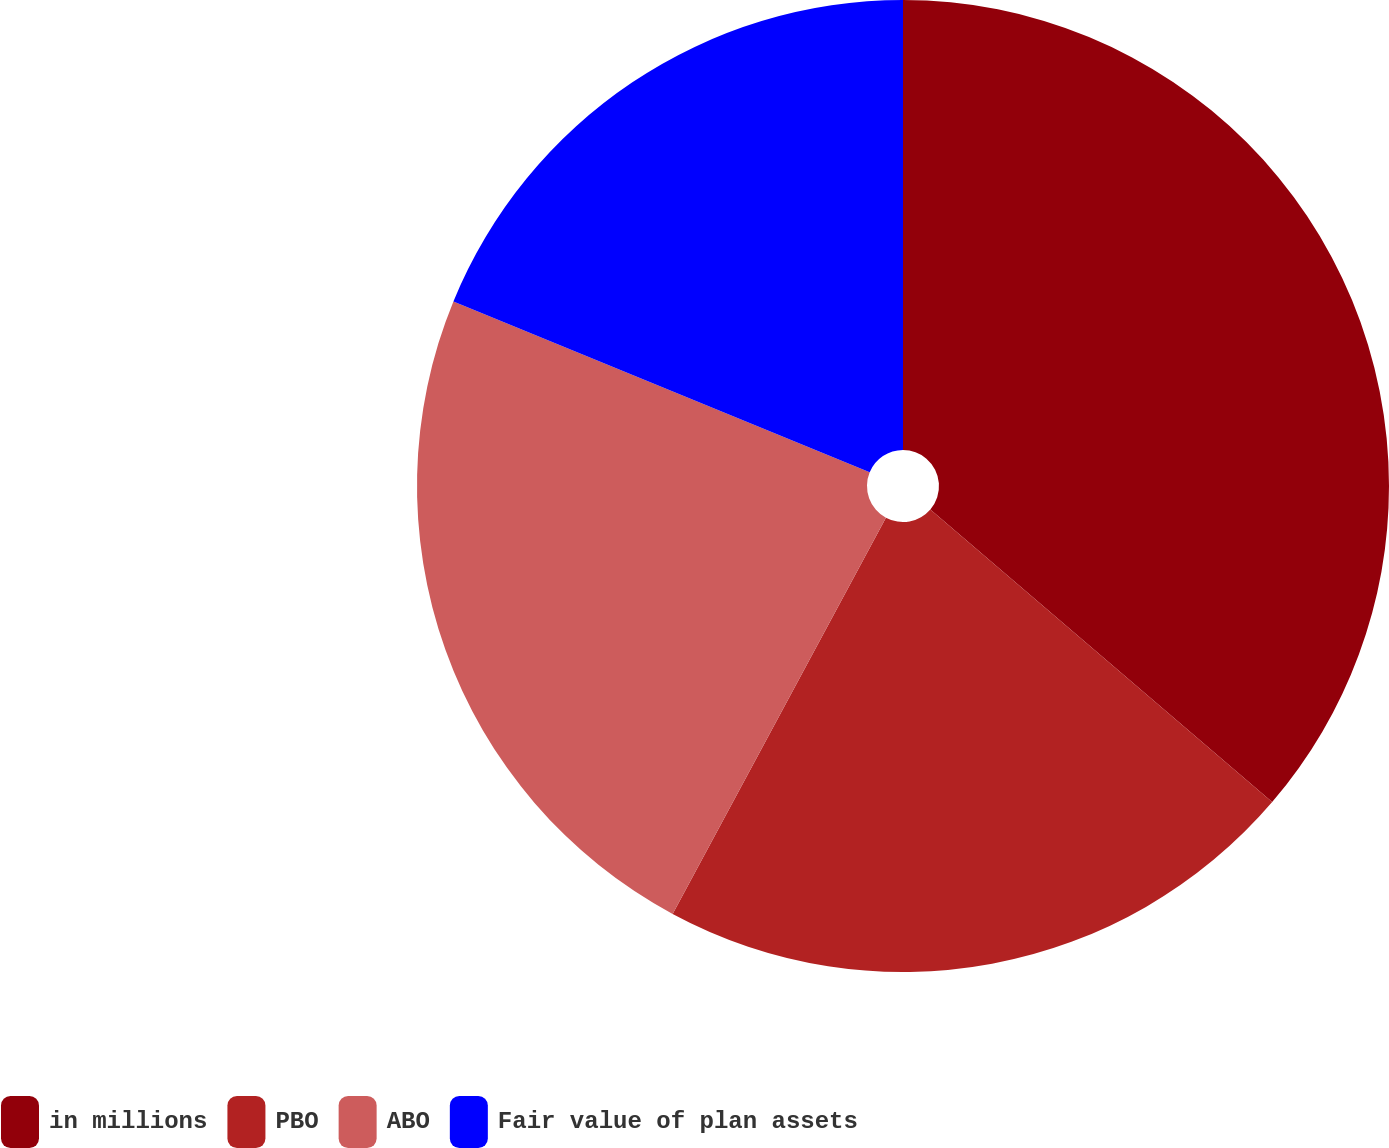<chart> <loc_0><loc_0><loc_500><loc_500><pie_chart><fcel>in millions<fcel>PBO<fcel>ABO<fcel>Fair value of plan assets<nl><fcel>36.27%<fcel>21.59%<fcel>23.34%<fcel>18.8%<nl></chart> 